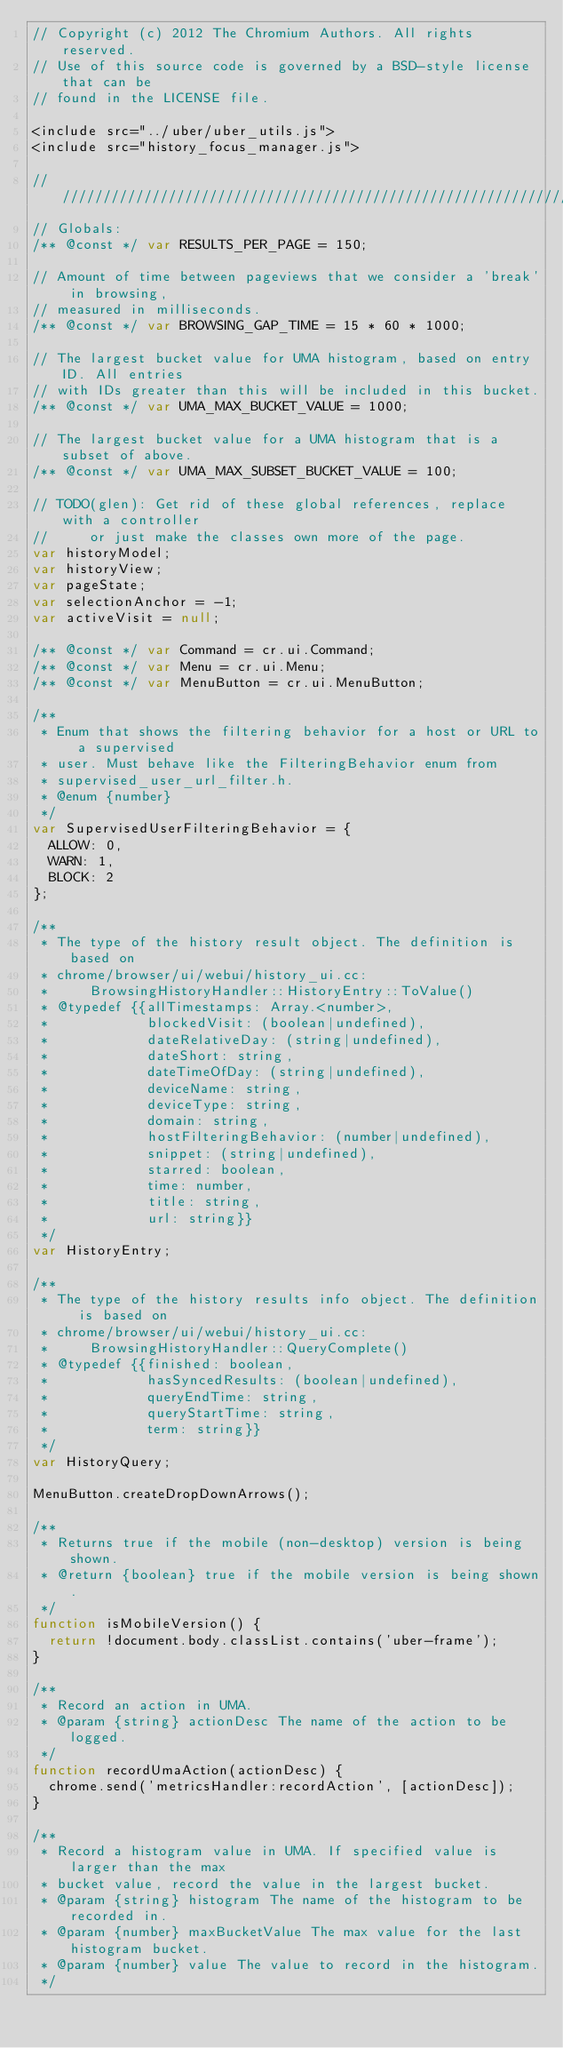<code> <loc_0><loc_0><loc_500><loc_500><_JavaScript_>// Copyright (c) 2012 The Chromium Authors. All rights reserved.
// Use of this source code is governed by a BSD-style license that can be
// found in the LICENSE file.

<include src="../uber/uber_utils.js">
<include src="history_focus_manager.js">

///////////////////////////////////////////////////////////////////////////////
// Globals:
/** @const */ var RESULTS_PER_PAGE = 150;

// Amount of time between pageviews that we consider a 'break' in browsing,
// measured in milliseconds.
/** @const */ var BROWSING_GAP_TIME = 15 * 60 * 1000;

// The largest bucket value for UMA histogram, based on entry ID. All entries
// with IDs greater than this will be included in this bucket.
/** @const */ var UMA_MAX_BUCKET_VALUE = 1000;

// The largest bucket value for a UMA histogram that is a subset of above.
/** @const */ var UMA_MAX_SUBSET_BUCKET_VALUE = 100;

// TODO(glen): Get rid of these global references, replace with a controller
//     or just make the classes own more of the page.
var historyModel;
var historyView;
var pageState;
var selectionAnchor = -1;
var activeVisit = null;

/** @const */ var Command = cr.ui.Command;
/** @const */ var Menu = cr.ui.Menu;
/** @const */ var MenuButton = cr.ui.MenuButton;

/**
 * Enum that shows the filtering behavior for a host or URL to a supervised
 * user. Must behave like the FilteringBehavior enum from
 * supervised_user_url_filter.h.
 * @enum {number}
 */
var SupervisedUserFilteringBehavior = {
  ALLOW: 0,
  WARN: 1,
  BLOCK: 2
};

/**
 * The type of the history result object. The definition is based on
 * chrome/browser/ui/webui/history_ui.cc:
 *     BrowsingHistoryHandler::HistoryEntry::ToValue()
 * @typedef {{allTimestamps: Array.<number>,
 *            blockedVisit: (boolean|undefined),
 *            dateRelativeDay: (string|undefined),
 *            dateShort: string,
 *            dateTimeOfDay: (string|undefined),
 *            deviceName: string,
 *            deviceType: string,
 *            domain: string,
 *            hostFilteringBehavior: (number|undefined),
 *            snippet: (string|undefined),
 *            starred: boolean,
 *            time: number,
 *            title: string,
 *            url: string}}
 */
var HistoryEntry;

/**
 * The type of the history results info object. The definition is based on
 * chrome/browser/ui/webui/history_ui.cc:
 *     BrowsingHistoryHandler::QueryComplete()
 * @typedef {{finished: boolean,
 *            hasSyncedResults: (boolean|undefined),
 *            queryEndTime: string,
 *            queryStartTime: string,
 *            term: string}}
 */
var HistoryQuery;

MenuButton.createDropDownArrows();

/**
 * Returns true if the mobile (non-desktop) version is being shown.
 * @return {boolean} true if the mobile version is being shown.
 */
function isMobileVersion() {
  return !document.body.classList.contains('uber-frame');
}

/**
 * Record an action in UMA.
 * @param {string} actionDesc The name of the action to be logged.
 */
function recordUmaAction(actionDesc) {
  chrome.send('metricsHandler:recordAction', [actionDesc]);
}

/**
 * Record a histogram value in UMA. If specified value is larger than the max
 * bucket value, record the value in the largest bucket.
 * @param {string} histogram The name of the histogram to be recorded in.
 * @param {number} maxBucketValue The max value for the last histogram bucket.
 * @param {number} value The value to record in the histogram.
 */</code> 